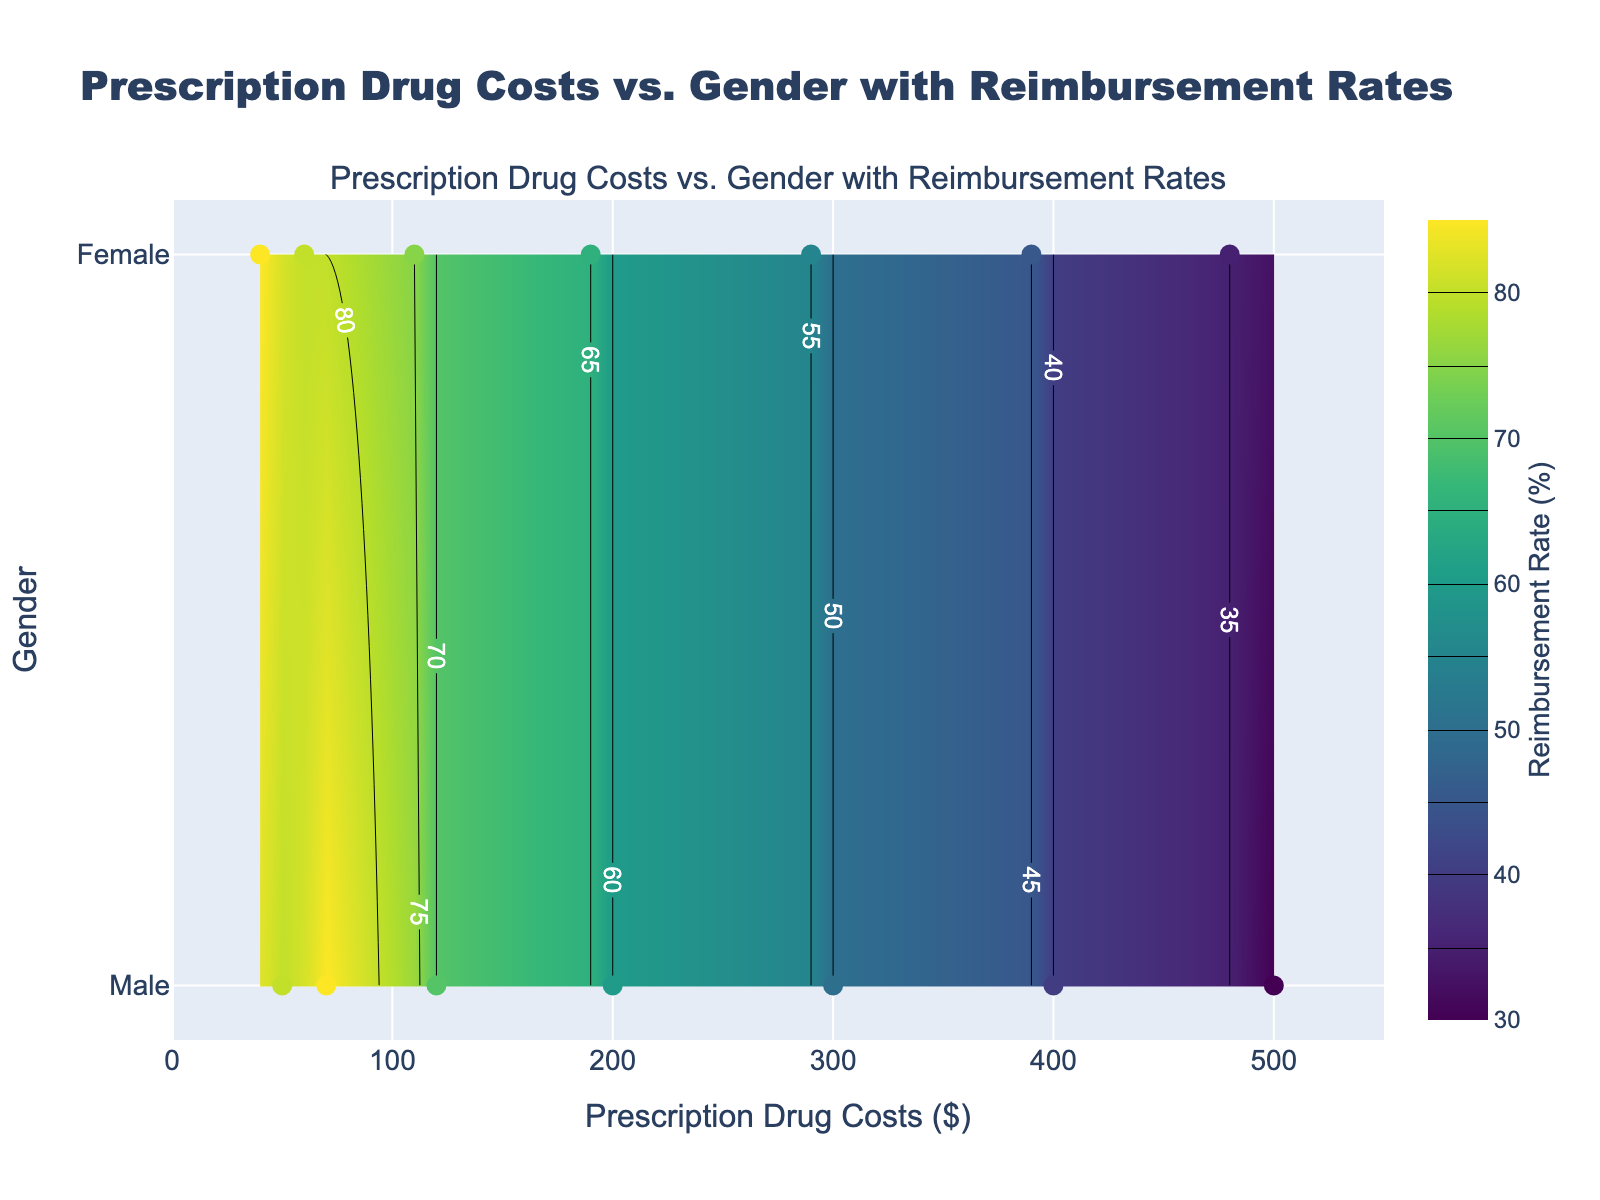What's the title of the figure? The title is usually located at the top of the figure and is meant to inform the viewer about what the plot is showing. In this case, it explicitly mentions the relationship being depicted.
Answer: Prescription Drug Costs vs. Gender with Reimbursement Rates What is the range of Prescription Drug Costs on the x-axis? The x-axis represents Prescription Drug Costs in dollars, and the range is indicated by the minimum and maximum values shown on the axis. From the figure, the range goes from 0 to 550 dollars.
Answer: 0 to 550 Which gender has the highest Reimbursement Rate at the lowest Prescription Drug Costs? By looking at the y-axis for gender and checking the contour lines and scatter points near the lowest drug costs on the x-axis, one can see which gender has the highest reimbursement rate.
Answer: Female What is the highest Reimbursement Rate shown on the color scale? The color bar on the right side of the plot displays the range of Reimbursement Rates used in the contour plot. The highest value is usually at the top of this scale.
Answer: 85% At what Prescription Drug Costs do both genders have equal Reimbursement Rates? To find where the Reimbursement Rates are equal for both genders, observe the contour lines where they converge or cross for both Male and Female categories.
Answer: 110 How does the Reimbursement Rate change as Prescription Drug Costs increase for males? By observing the contour lines and scatter points for males from left to right on the plot, you can see how the Reimbursement Rates vary as the drug costs increase.
Answer: It decreases Is the Reimbursement Rate higher for females or males at $200 Prescription Drug Costs? Locate the $200 mark on the x-axis and compare the Reimbursement Rates for both genders at that point by looking at the associated contour levels.
Answer: Females What is the average Reimbursement Rate for Prescription Drug Costs at $300? Identify the Reimbursement Rates for both genders at $300 from the contour and scatter points, then calculate their average. For $300, the rates are 50% for males and 55% for females. So, the average is (50 + 55) / 2.
Answer: 52.5% At which Prescription Drug Costs do we observe the greatest difference in Reimbursement Rates between genders? Compare the differences in Reimbursement Rates for various drug cost levels by observing the contour lines. The greatest difference is found where the discrepancy between the contour lines for males and females is the widest.
Answer: 70 